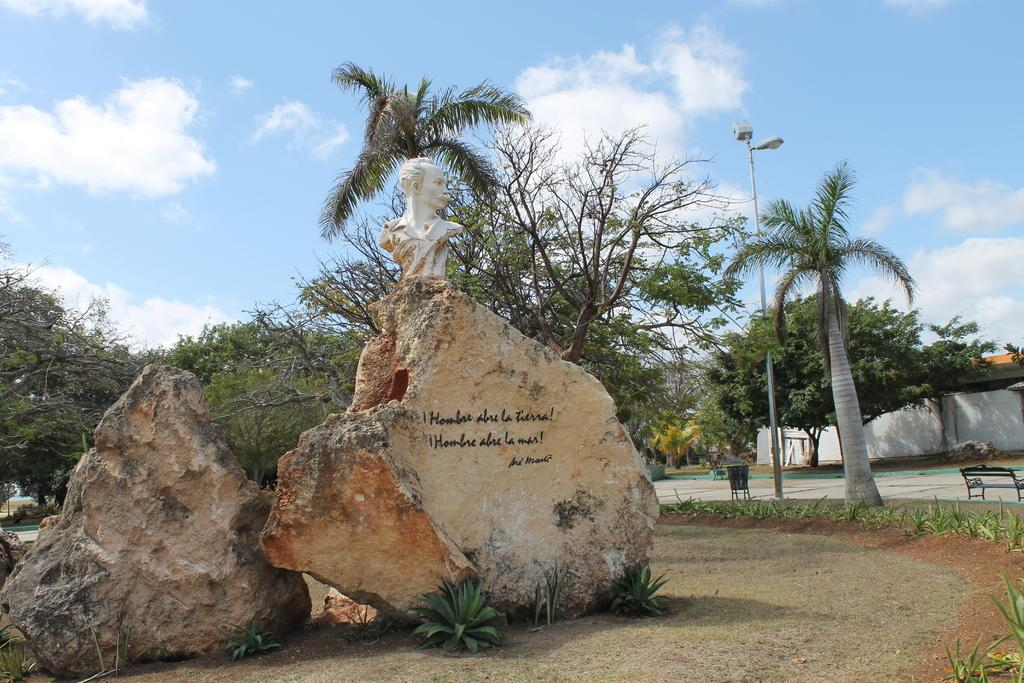How many rocks can be seen in the image? There are two rocks in the image. What is on one of the rocks? There is a statue on one of the rocks. What type of vegetation is present in the image? There are plants and trees in the image. Where is the bench located in the image? The bench is on the right side of the image. What are the poles with lights used for? The poles with lights are likely used for illumination. What is the condition of the sky in the image? The sky is clear in the image. What type of skirt is draped over the statue in the image? There is no skirt present in the image; the statue is on a rock. What observation can be made about the line of trees in the image? There is no line of trees mentioned in the image; there are only individual trees present. 